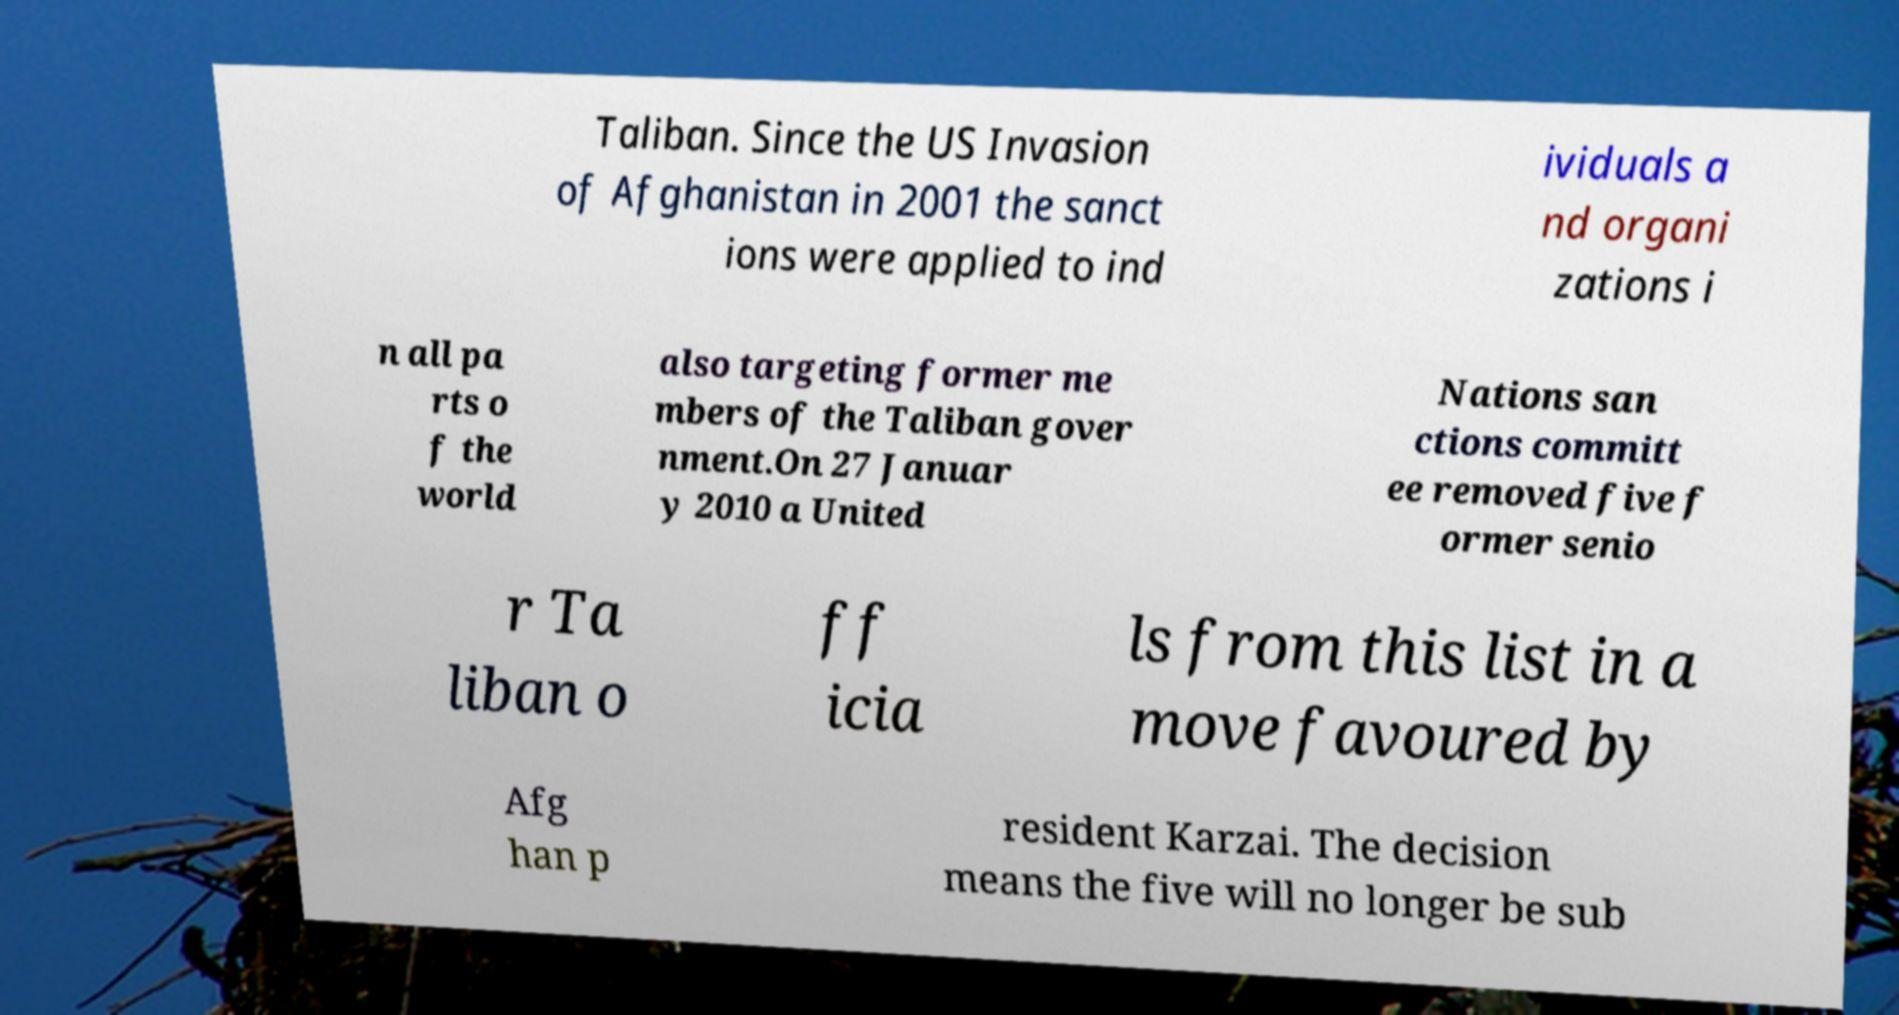I need the written content from this picture converted into text. Can you do that? Taliban. Since the US Invasion of Afghanistan in 2001 the sanct ions were applied to ind ividuals a nd organi zations i n all pa rts o f the world also targeting former me mbers of the Taliban gover nment.On 27 Januar y 2010 a United Nations san ctions committ ee removed five f ormer senio r Ta liban o ff icia ls from this list in a move favoured by Afg han p resident Karzai. The decision means the five will no longer be sub 